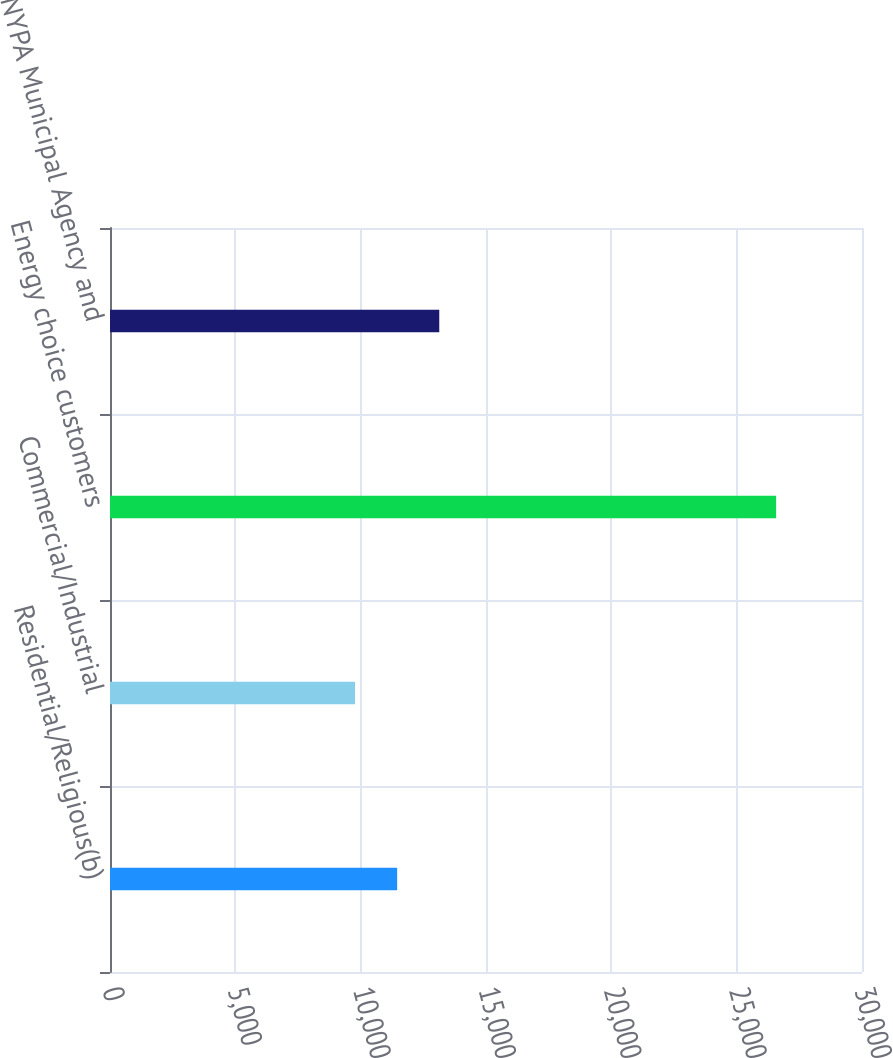Convert chart to OTSL. <chart><loc_0><loc_0><loc_500><loc_500><bar_chart><fcel>Residential/Religious(b)<fcel>Commercial/Industrial<fcel>Energy choice customers<fcel>NYPA Municipal Agency and<nl><fcel>11455.8<fcel>9776<fcel>26574<fcel>13135.6<nl></chart> 